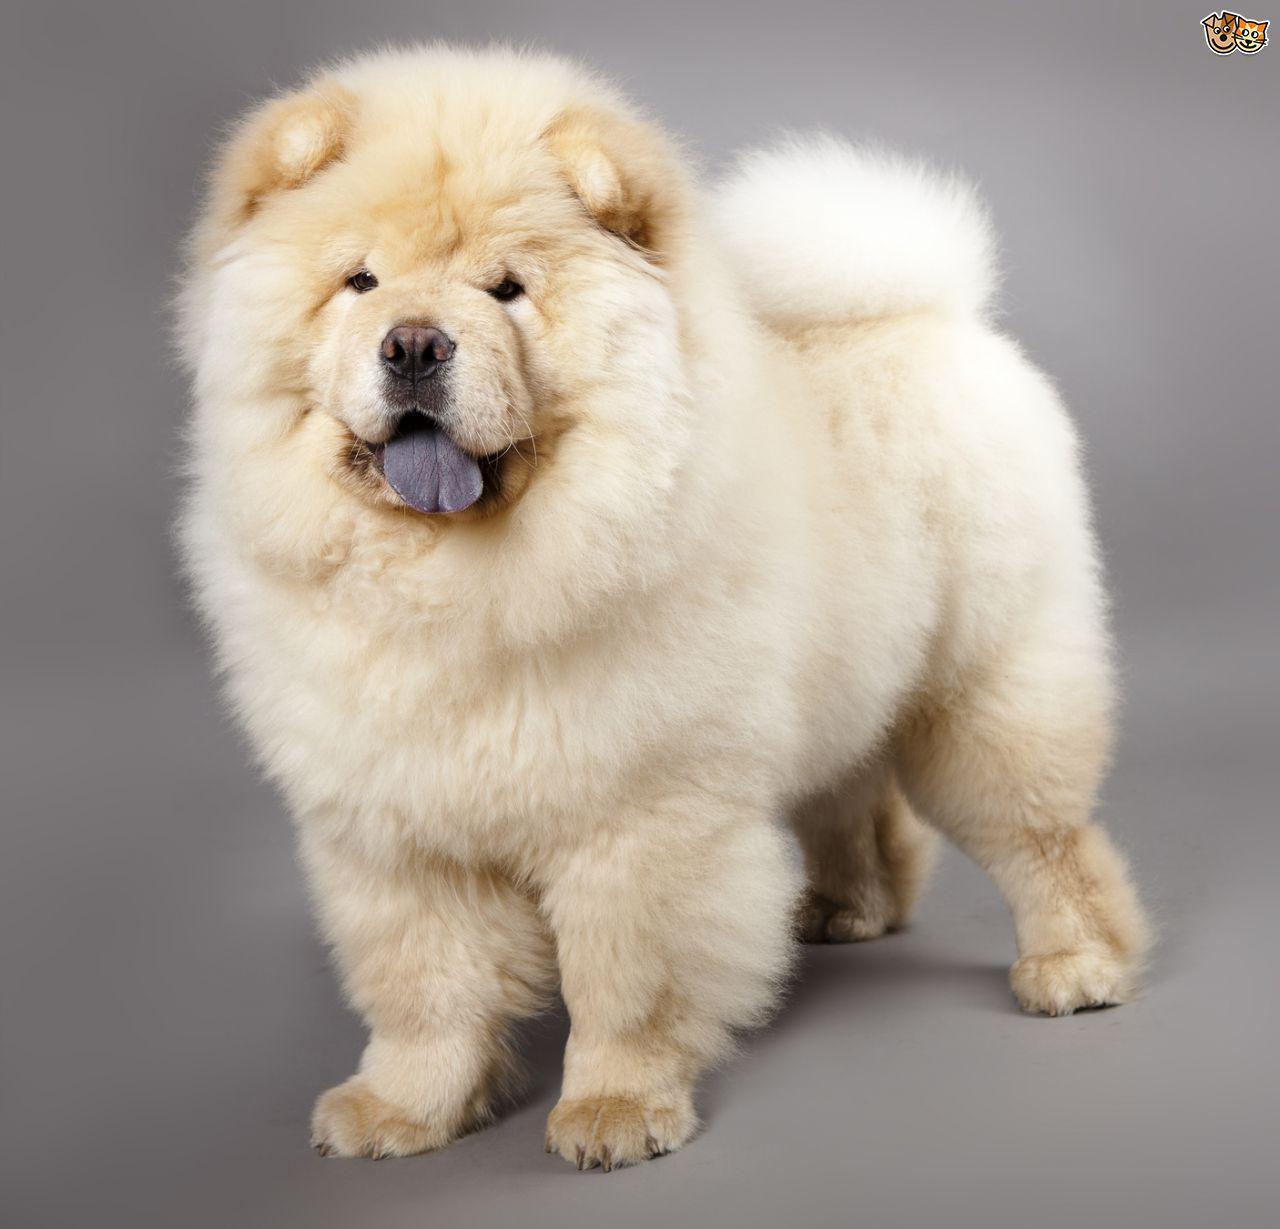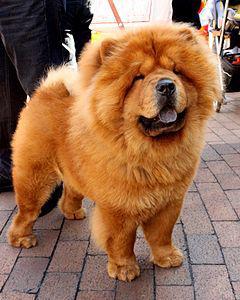The first image is the image on the left, the second image is the image on the right. For the images shown, is this caption "The dog in the image on the right is standing on all fours in the grass." true? Answer yes or no. No. The first image is the image on the left, the second image is the image on the right. Evaluate the accuracy of this statement regarding the images: "All images show exactly one chow dog standing on all fours.". Is it true? Answer yes or no. Yes. 